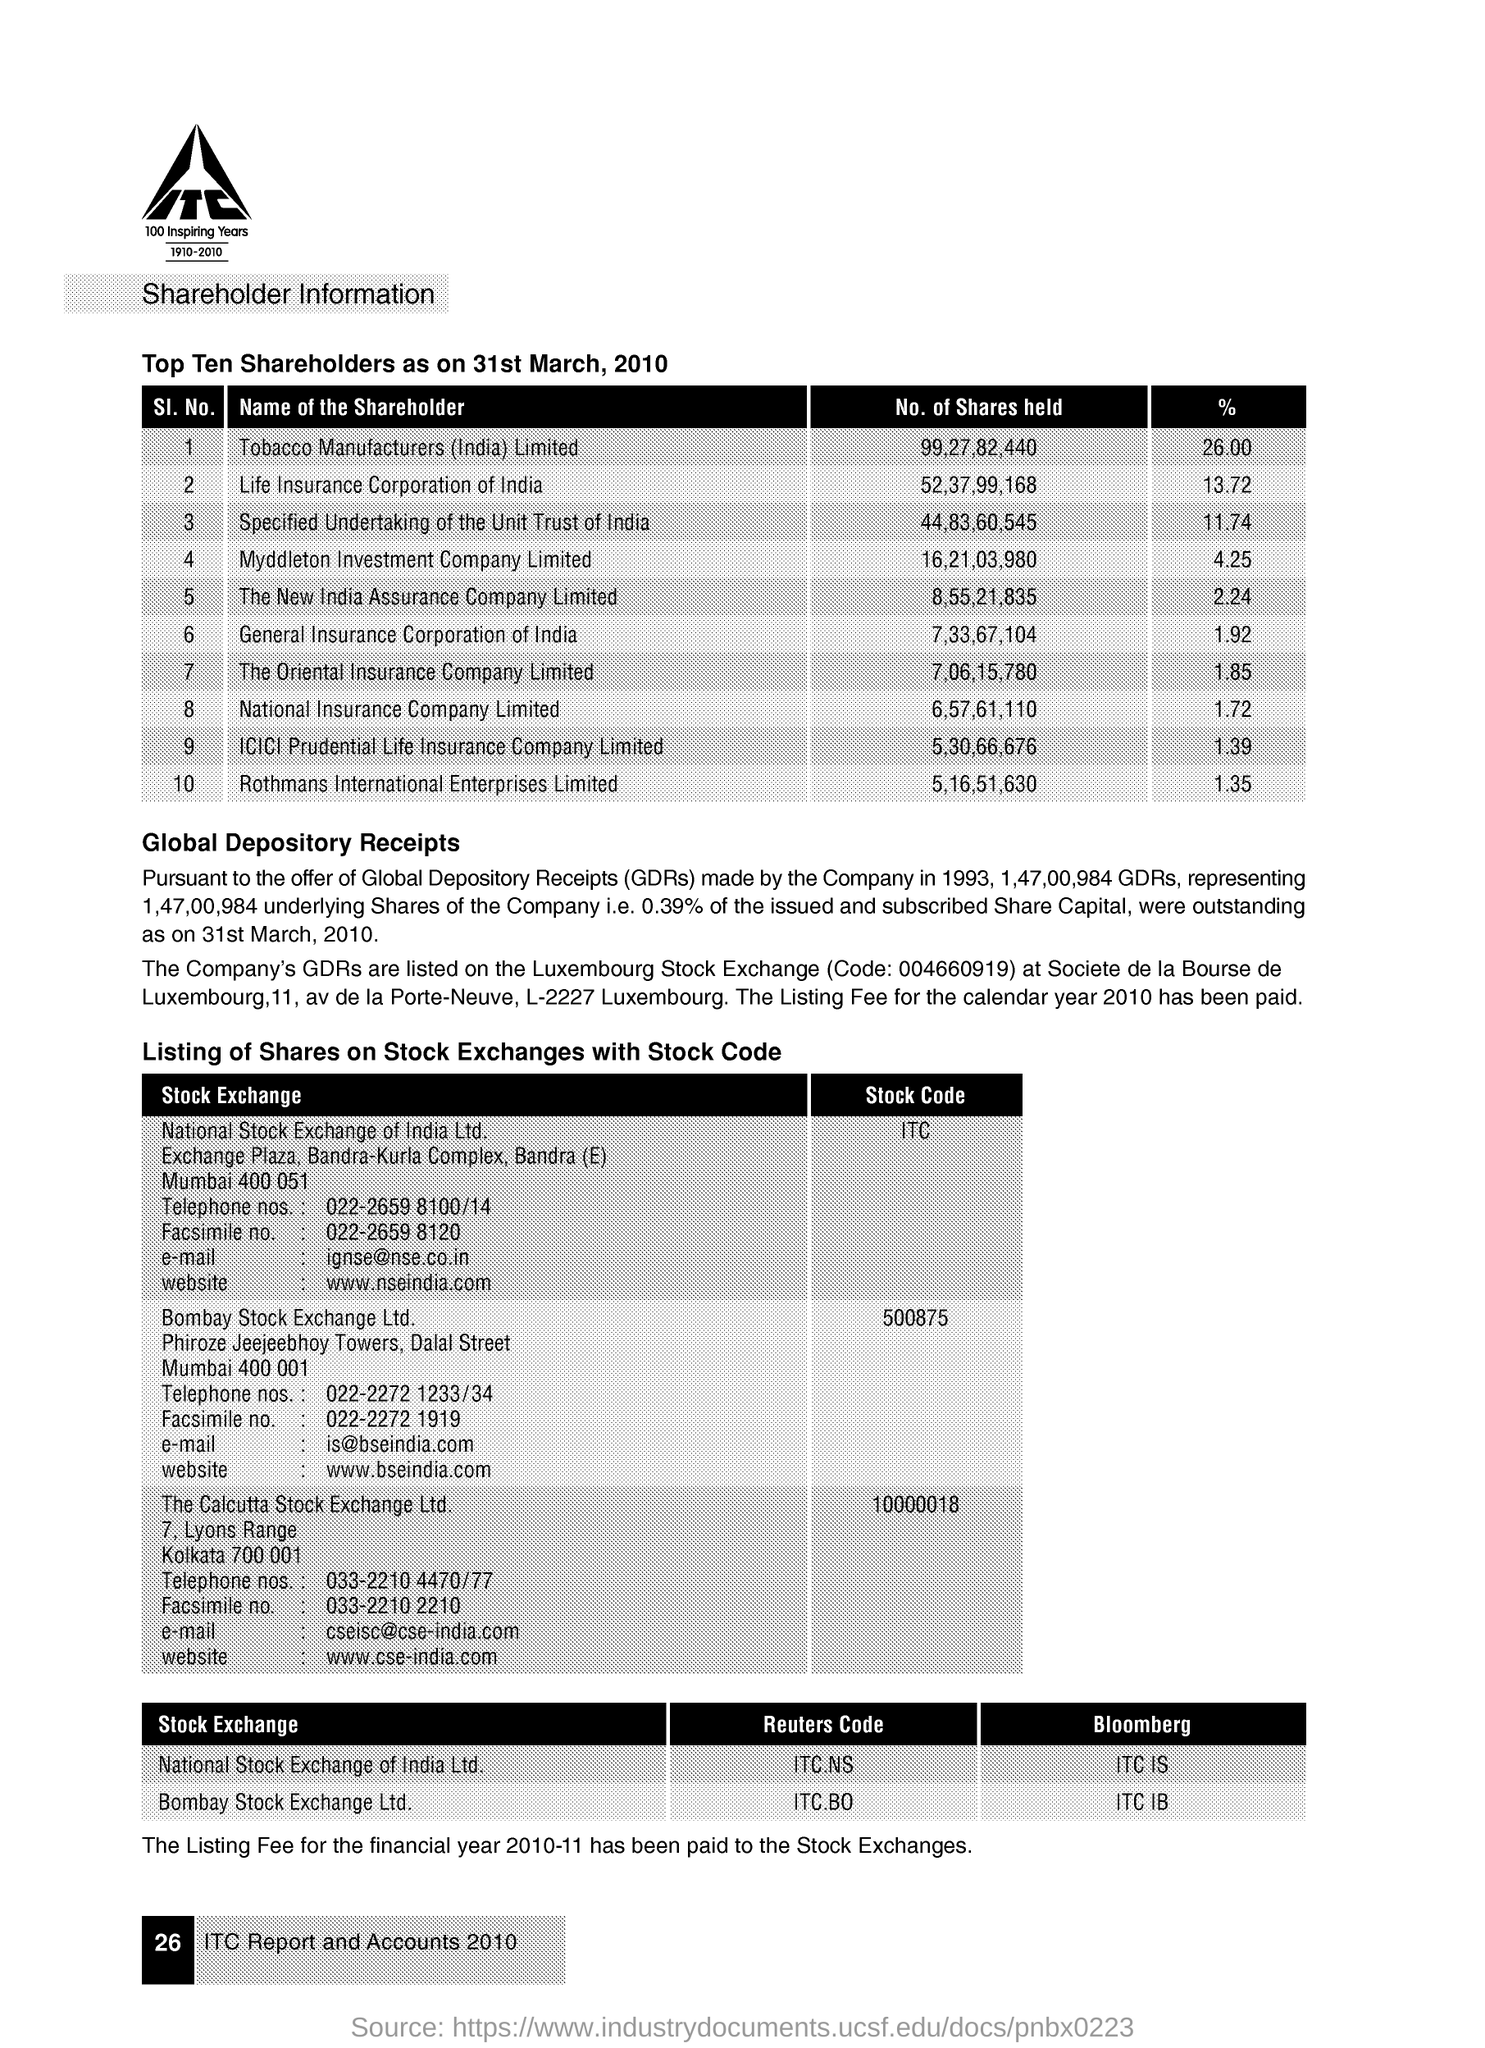How many no of share holders are held in the tobacco manufactures (india) limited ?
Provide a succinct answer. 99,27,82,440. What is the % of shares in the national insurance company limited?
Your answer should be very brief. 1.72. How many no of share holders are held in the general insurance corporation of india?
Your answer should be compact. 7,33,67,104. What is the % of shares held in the new india assurance company limited ?
Your answer should be compact. 2.24. How many no of shares are held in the life insurance corporation of india ?
Give a very brief answer. 52,37,99,168. What is the % of shares held in the oriental insurance company limited ?
Make the answer very short. 1.85. How many no of shares are held in the rothmans international enterprises limited ?
Keep it short and to the point. 5,16,51,630. What is the reuters code for national stock exchange of india ltd?
Offer a terse response. ITC.NS. How many no of shares are held in the icici prudential life insurance company limited ?
Give a very brief answer. 5,30,66,676. What is the % of shares held in the specified undertaking of the unit trust of india ?
Keep it short and to the point. 11.74. 